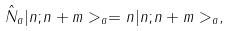<formula> <loc_0><loc_0><loc_500><loc_500>\hat { N } _ { a } | n ; n + m > _ { a } = n | n ; n + m > _ { a } ,</formula> 